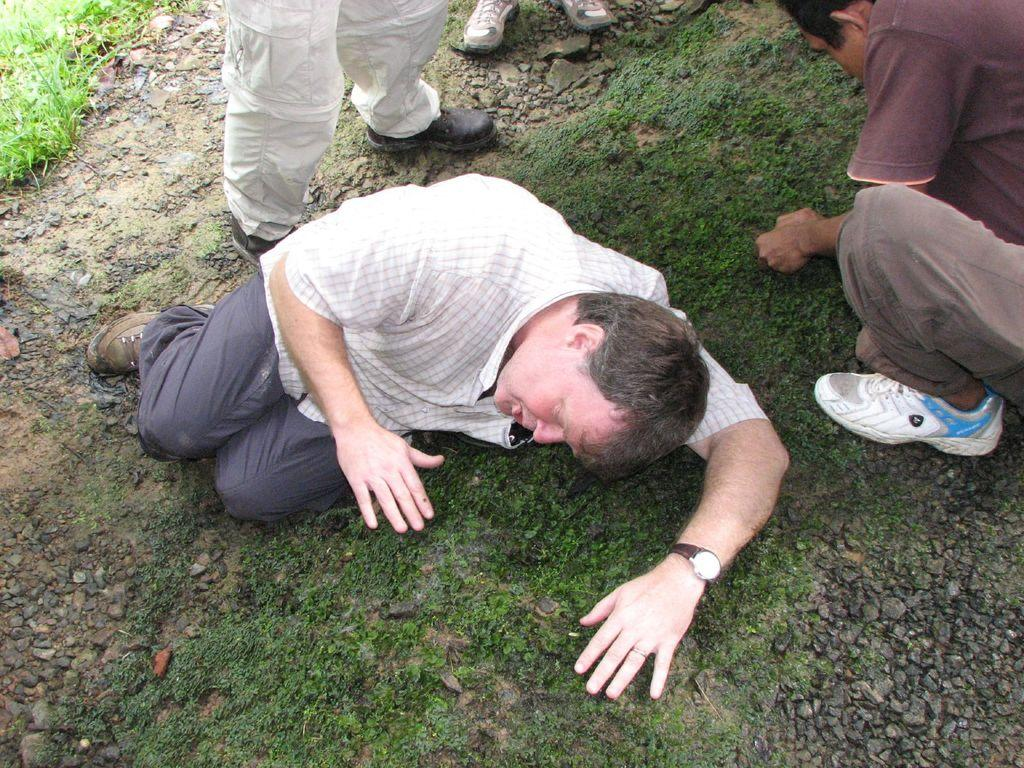Who or what can be seen in the image? There are people in the image. What type of natural environment is present in the image? There is grass in the image. Are there any objects or features made of stone in the image? Yes, there are stones in the image. What is the position of the man in the image? A man is lying on the grass in the middle of the image. Can you see a basketball game happening in the image? No, there is no basketball game or any reference to basketball in the image. 